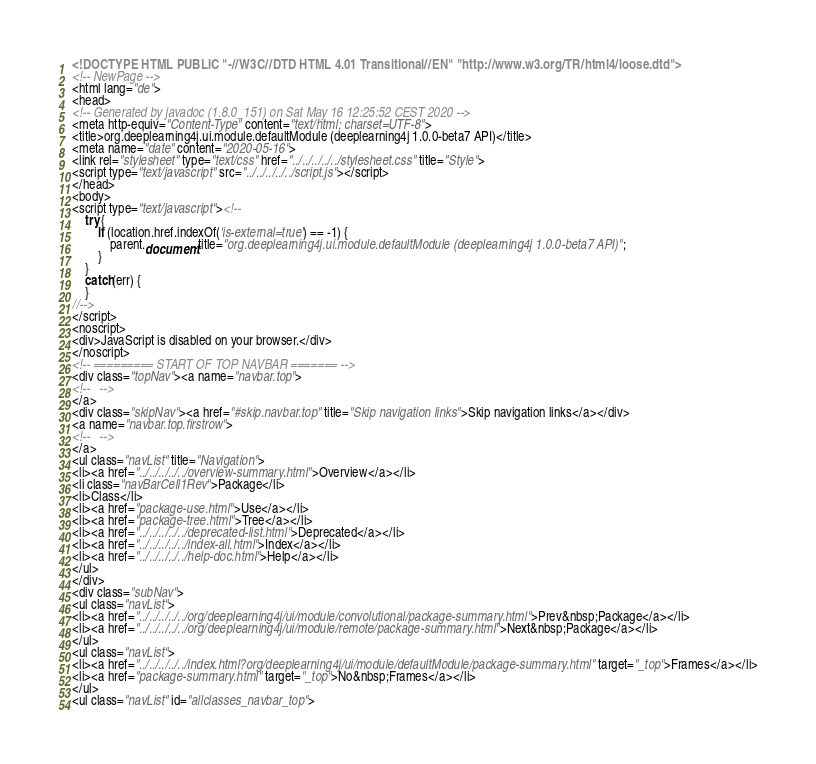Convert code to text. <code><loc_0><loc_0><loc_500><loc_500><_HTML_><!DOCTYPE HTML PUBLIC "-//W3C//DTD HTML 4.01 Transitional//EN" "http://www.w3.org/TR/html4/loose.dtd">
<!-- NewPage -->
<html lang="de">
<head>
<!-- Generated by javadoc (1.8.0_151) on Sat May 16 12:25:52 CEST 2020 -->
<meta http-equiv="Content-Type" content="text/html; charset=UTF-8">
<title>org.deeplearning4j.ui.module.defaultModule (deeplearning4j 1.0.0-beta7 API)</title>
<meta name="date" content="2020-05-16">
<link rel="stylesheet" type="text/css" href="../../../../../stylesheet.css" title="Style">
<script type="text/javascript" src="../../../../../script.js"></script>
</head>
<body>
<script type="text/javascript"><!--
    try {
        if (location.href.indexOf('is-external=true') == -1) {
            parent.document.title="org.deeplearning4j.ui.module.defaultModule (deeplearning4j 1.0.0-beta7 API)";
        }
    }
    catch(err) {
    }
//-->
</script>
<noscript>
<div>JavaScript is disabled on your browser.</div>
</noscript>
<!-- ========= START OF TOP NAVBAR ======= -->
<div class="topNav"><a name="navbar.top">
<!--   -->
</a>
<div class="skipNav"><a href="#skip.navbar.top" title="Skip navigation links">Skip navigation links</a></div>
<a name="navbar.top.firstrow">
<!--   -->
</a>
<ul class="navList" title="Navigation">
<li><a href="../../../../../overview-summary.html">Overview</a></li>
<li class="navBarCell1Rev">Package</li>
<li>Class</li>
<li><a href="package-use.html">Use</a></li>
<li><a href="package-tree.html">Tree</a></li>
<li><a href="../../../../../deprecated-list.html">Deprecated</a></li>
<li><a href="../../../../../index-all.html">Index</a></li>
<li><a href="../../../../../help-doc.html">Help</a></li>
</ul>
</div>
<div class="subNav">
<ul class="navList">
<li><a href="../../../../../org/deeplearning4j/ui/module/convolutional/package-summary.html">Prev&nbsp;Package</a></li>
<li><a href="../../../../../org/deeplearning4j/ui/module/remote/package-summary.html">Next&nbsp;Package</a></li>
</ul>
<ul class="navList">
<li><a href="../../../../../index.html?org/deeplearning4j/ui/module/defaultModule/package-summary.html" target="_top">Frames</a></li>
<li><a href="package-summary.html" target="_top">No&nbsp;Frames</a></li>
</ul>
<ul class="navList" id="allclasses_navbar_top"></code> 